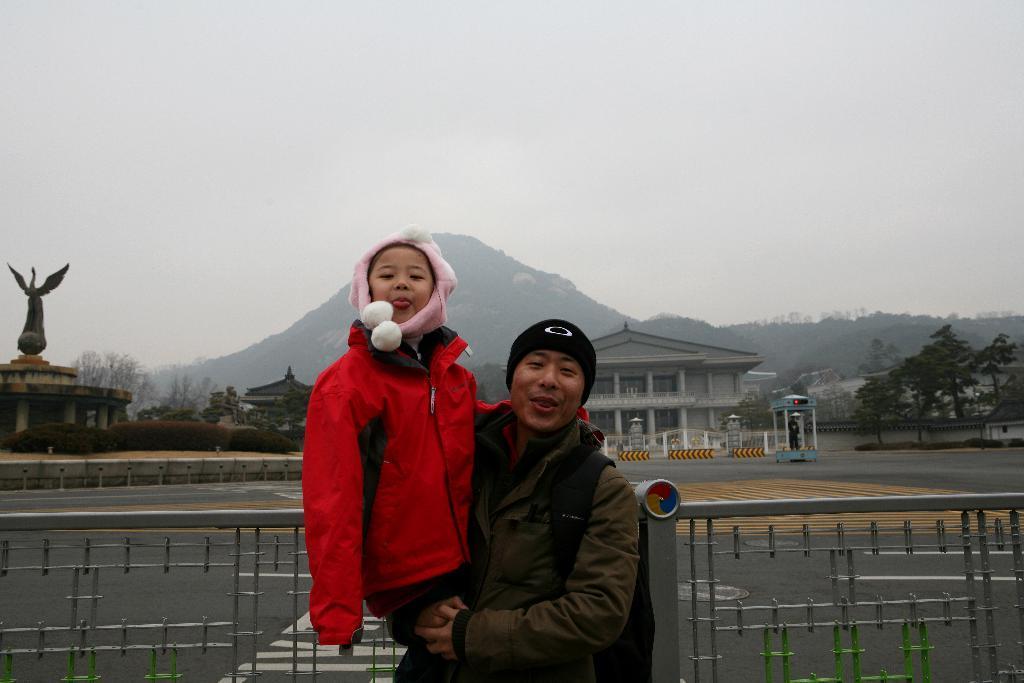Can you describe this image briefly? In this image we can see two persons. A person is carrying a baby. There is a hill and many buildings in the image. There many trees in the image. There is a road in the image. 